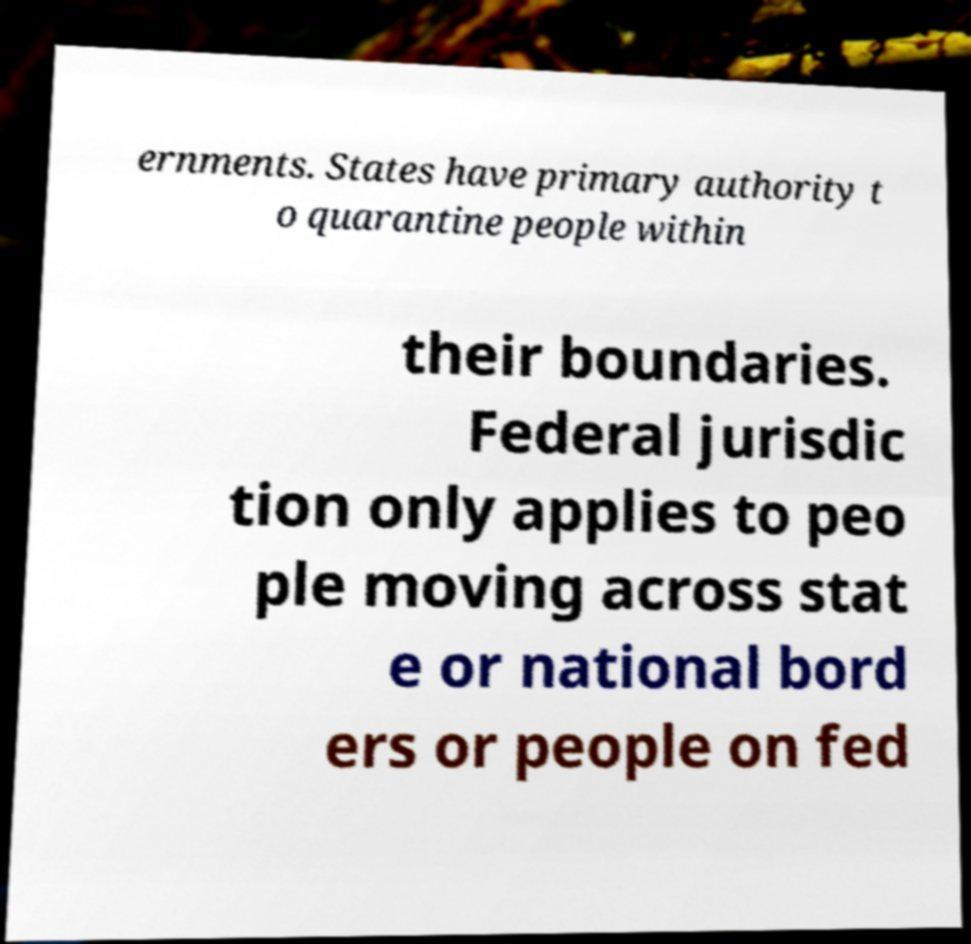Could you assist in decoding the text presented in this image and type it out clearly? ernments. States have primary authority t o quarantine people within their boundaries. Federal jurisdic tion only applies to peo ple moving across stat e or national bord ers or people on fed 